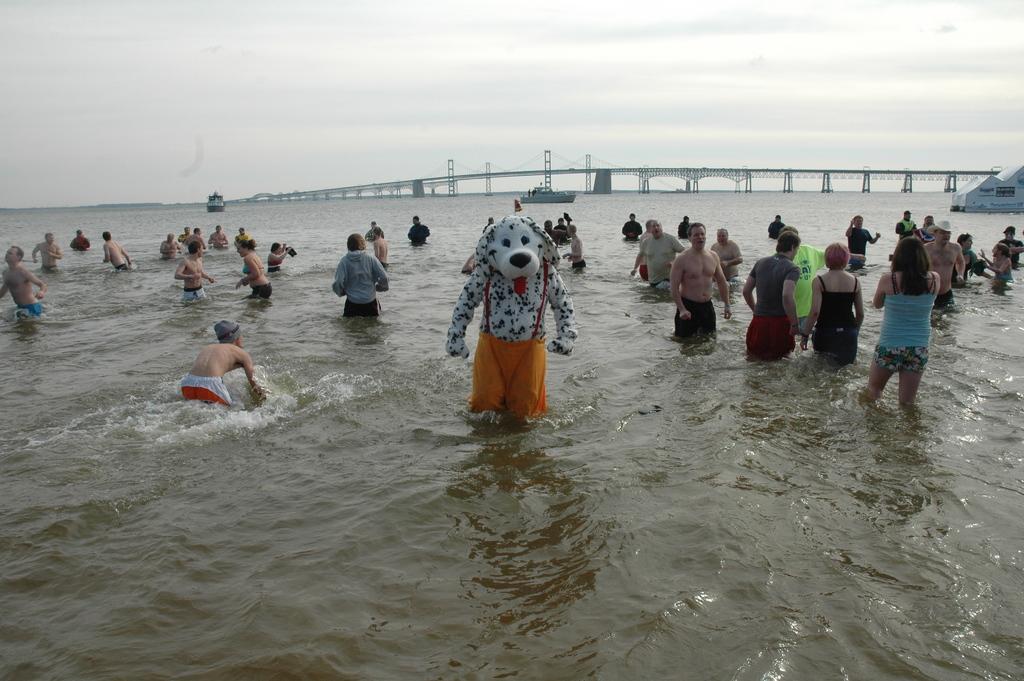How would you summarize this image in a sentence or two? Here we can see water and people. Far there is a bridge. Sky is cloudy. Above this water there are boats. 